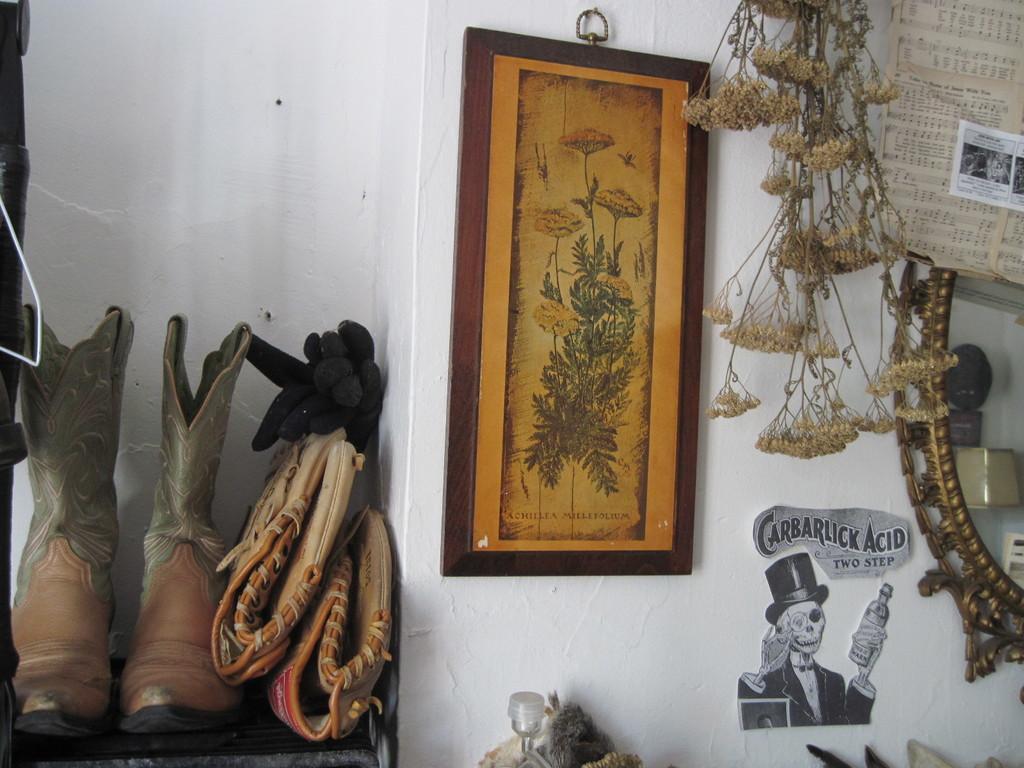In one or two sentences, can you explain what this image depicts? This picture is clicked inside the room. On the left we can see a rack containing shoes and some objects. On the right we can see a picture frame hanging on the wall and the picture frame is containing the depiction of the plant and the text. On the right we can see the text on the poster which seems to be hanging on the wall and we can see some objects are hanging on the wall and we can see the text and the depictions of some objects are attached to the wall. In the right corner we can see a metal object and some other objects. In the foreground we can see some objects. In the background we can see the wall. 